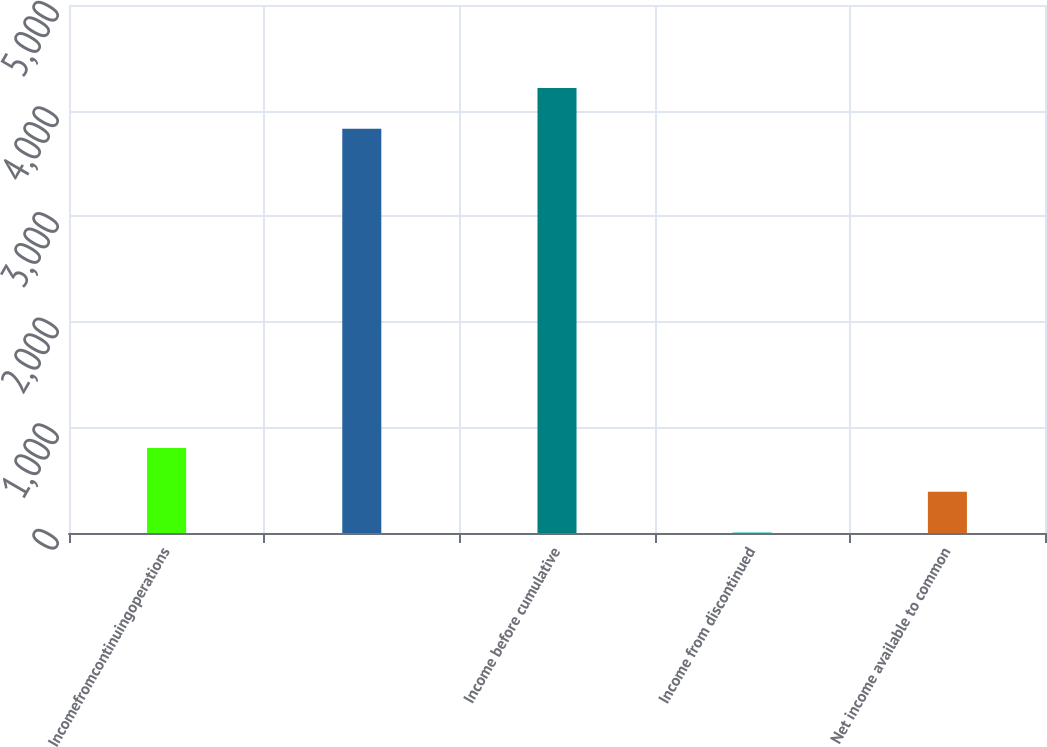Convert chart to OTSL. <chart><loc_0><loc_0><loc_500><loc_500><bar_chart><fcel>Incomefromcontinuingoperations<fcel>Unnamed: 1<fcel>Income before cumulative<fcel>Income from discontinued<fcel>Net income available to common<nl><fcel>806<fcel>3829<fcel>4214.9<fcel>4.02<fcel>389.92<nl></chart> 